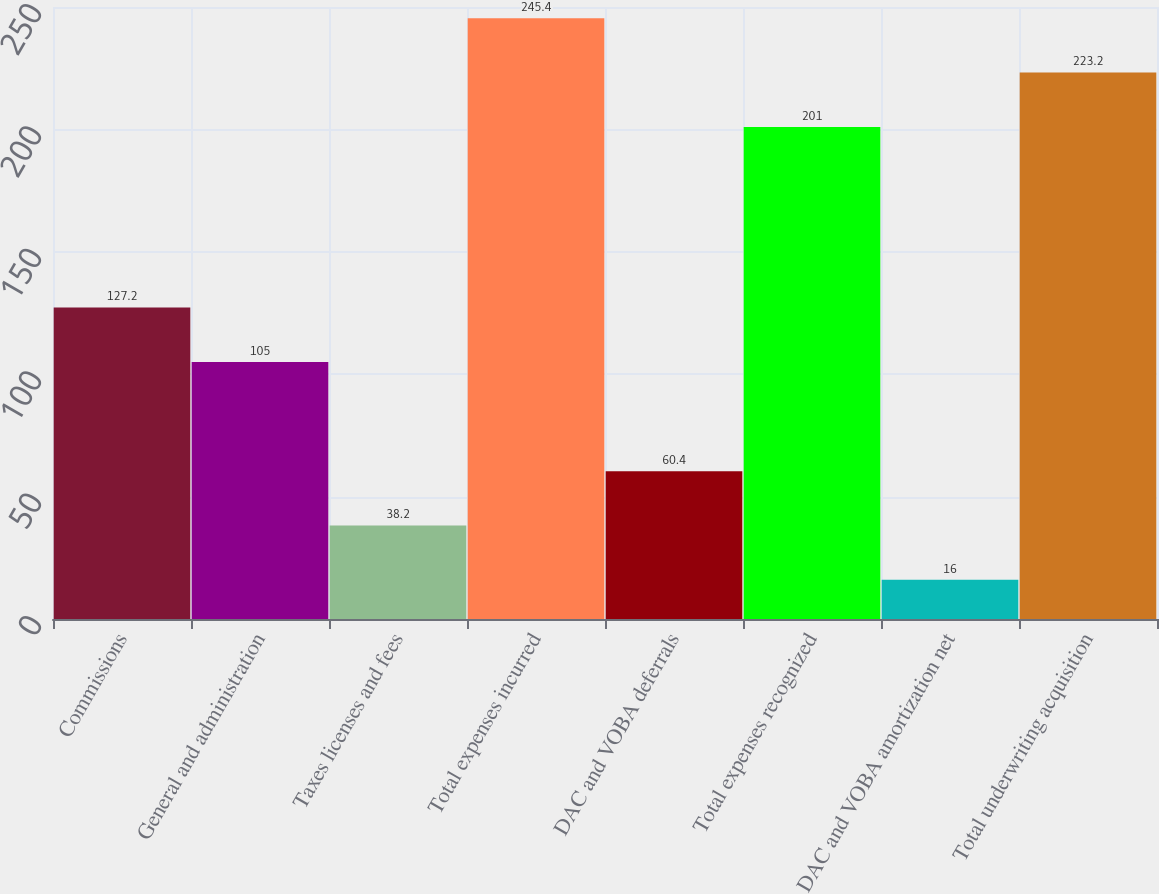<chart> <loc_0><loc_0><loc_500><loc_500><bar_chart><fcel>Commissions<fcel>General and administration<fcel>Taxes licenses and fees<fcel>Total expenses incurred<fcel>DAC and VOBA deferrals<fcel>Total expenses recognized<fcel>DAC and VOBA amortization net<fcel>Total underwriting acquisition<nl><fcel>127.2<fcel>105<fcel>38.2<fcel>245.4<fcel>60.4<fcel>201<fcel>16<fcel>223.2<nl></chart> 